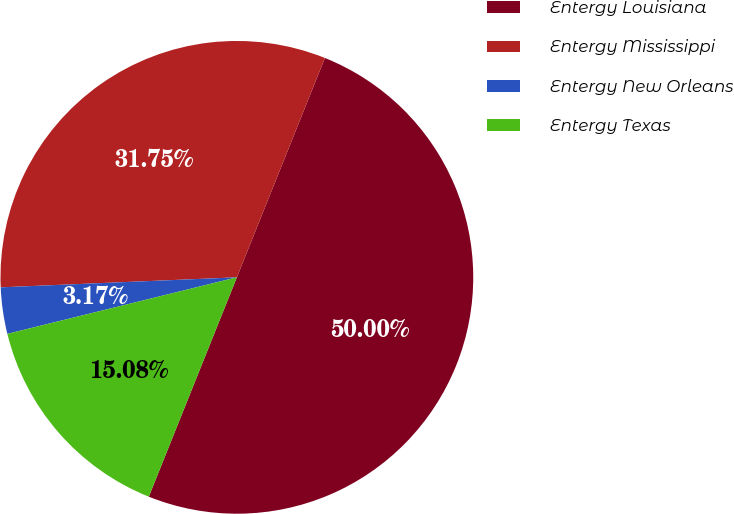Convert chart. <chart><loc_0><loc_0><loc_500><loc_500><pie_chart><fcel>Entergy Louisiana<fcel>Entergy Mississippi<fcel>Entergy New Orleans<fcel>Entergy Texas<nl><fcel>50.0%<fcel>31.75%<fcel>3.17%<fcel>15.08%<nl></chart> 